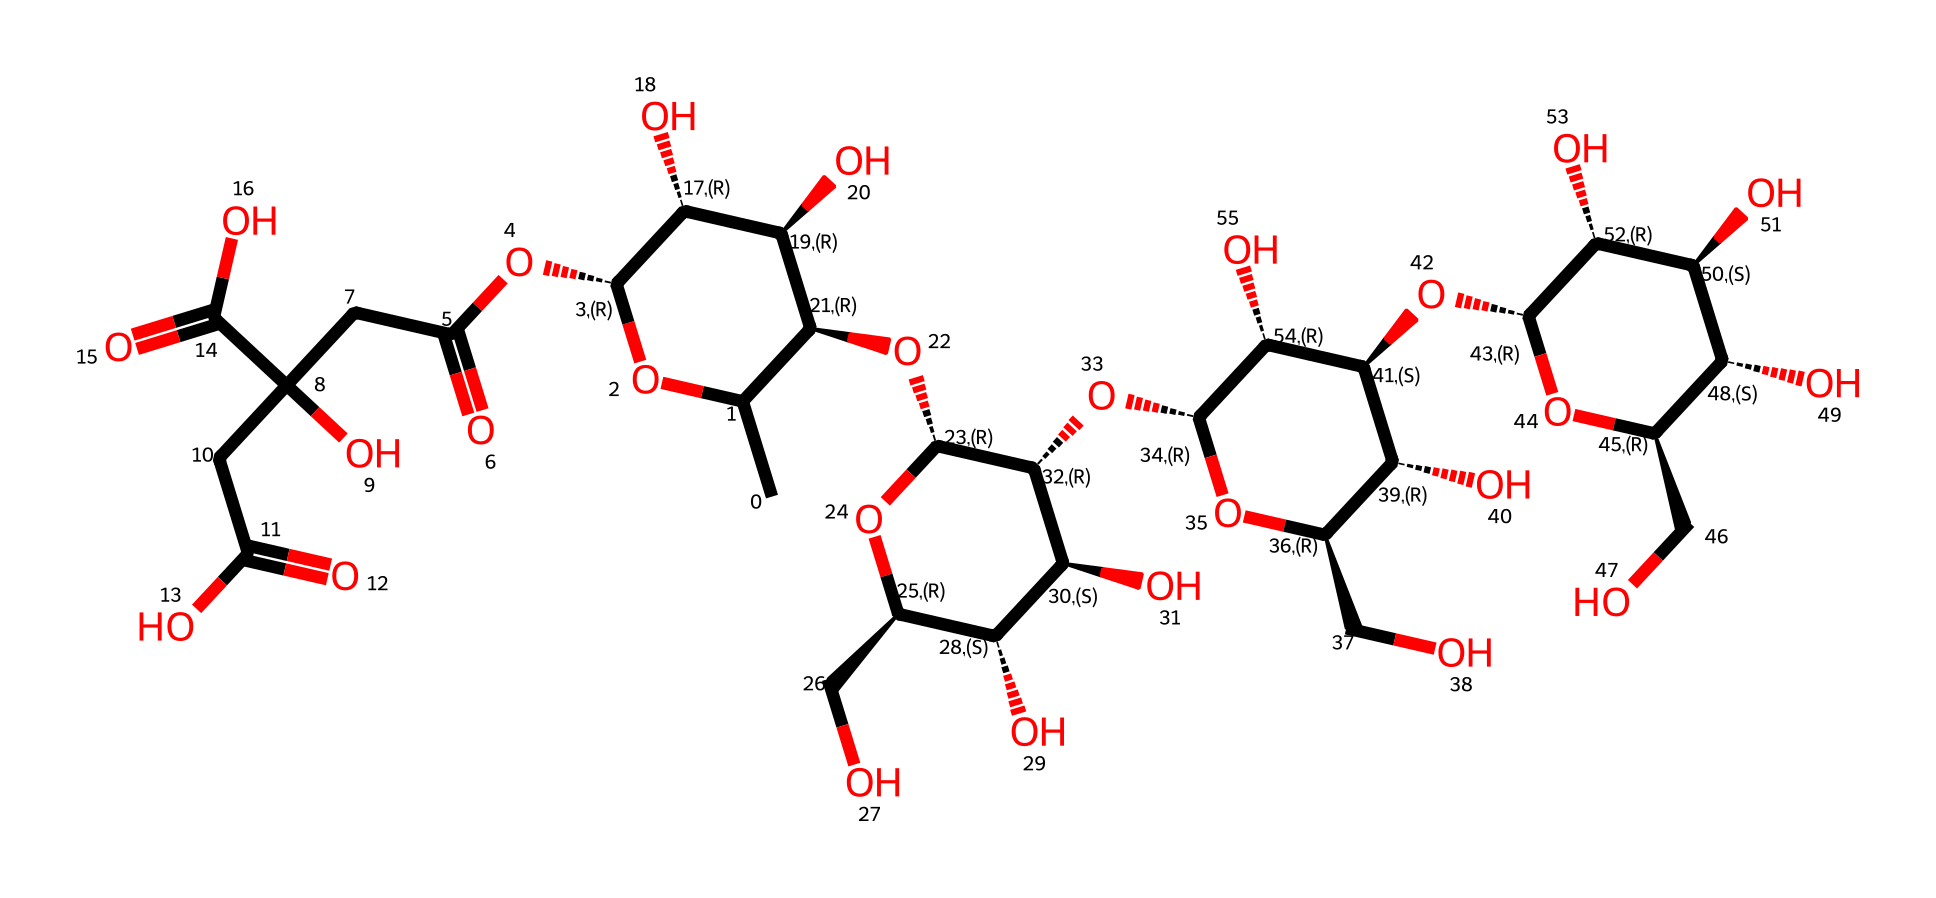what is the name of this compound? The SMILES representation corresponds to xanthan gum, a polysaccharide used as a thickening agent.
Answer: xanthan gum how many carbon atoms are present in the structure? By meticulously counting the carbon (C) symbols in the SMILES representation, there are 20 carbon atoms within the compound.
Answer: 20 what type of functional groups are indicated in this compound? The presence of -OH (hydroxyl groups) and -O- (ether linkages) can be identified within the structure.
Answer: hydroxyl and ether how does xanthan gum behave when mixed with water? Xanthan gum is classified as a non-Newtonian fluid, showing shear-thinning properties where it becomes less viscous under stress.
Answer: shear-thinning what is one primary application of xanthan gum in the art world? Xanthan gum is used in paint formulations as a thickener and stabilizer, enhancing texture and preventing separation.
Answer: thickener and stabilizer how many rings are present in the xanthan gum structure? The visual representation, along with the SMILES interpretation, shows that there are three cyclic structures (rings) incorporated in xanthan gum.
Answer: three what role does xanthan gum play in paint preservation? The polymer structure creates a stable environment that enhances the longevity and shelf-life of paint by minimizing phase separation.
Answer: stability 